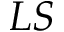<formula> <loc_0><loc_0><loc_500><loc_500>L S</formula> 